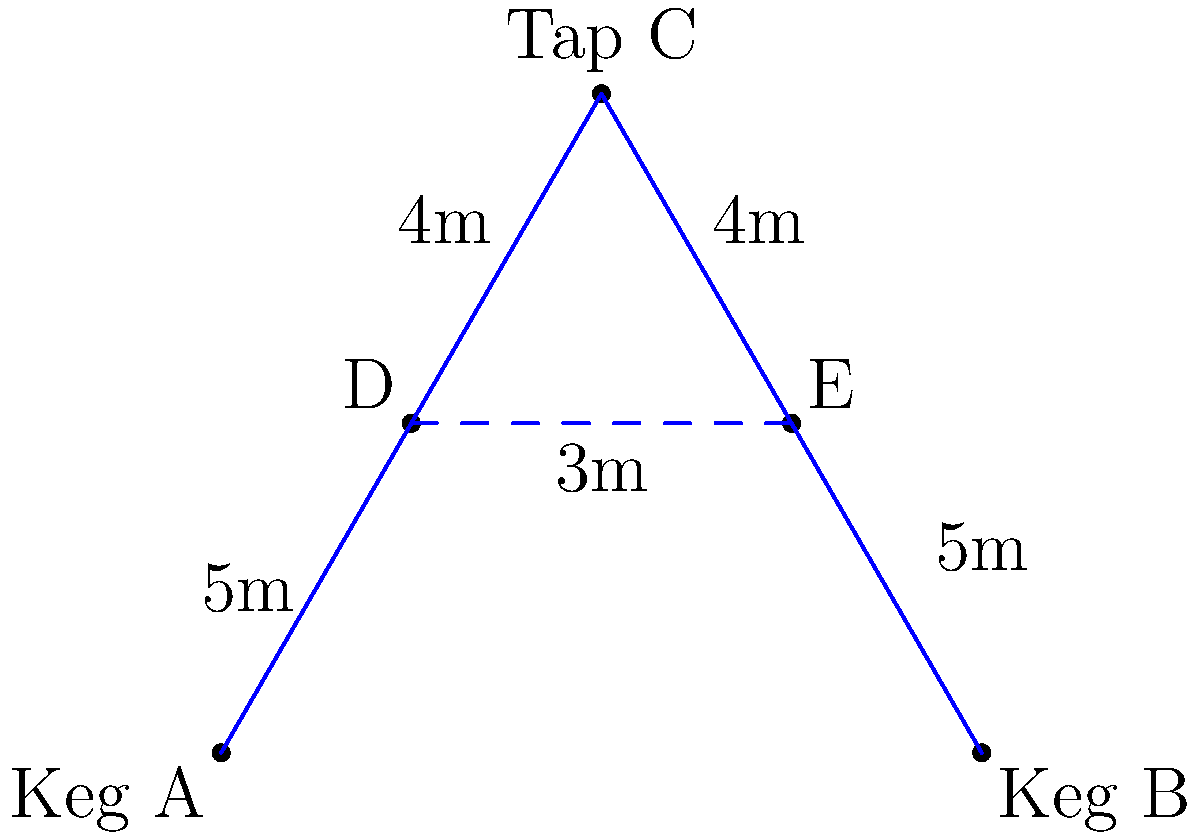You're designing the pipeline network for a beer festival. Two kegs (A and B) need to be connected to a central tap (C). The distances between points are shown in the diagram. What is the minimum total length of piping needed to connect both kegs to the tap, assuming you can place junction points (D and E) anywhere along the lines AC and BC? To solve this problem, we need to use the concept of the Steiner tree, which provides the minimum spanning network for a given set of points. Here's how we can approach this:

1) First, we observe that the optimal solution will involve two junction points (D and E) on the lines AC and BC respectively.

2) The key is to find the positions of D and E that minimize the total length of AD + BD + DE + DC.

3) In the optimal configuration, the angles ∠ADE, ∠BED, and ∠CDE should all be 120°. This is a property of Steiner points in the minimum Steiner tree.

4) Given this 120° angle condition, we can determine that triangle CDE is equilateral.

5) The height of this equilateral triangle (distance from C to DE) is $4 \sin 60° = 2\sqrt{3}$ meters.

6) The total length of the network is then:
   $AD + BE + 2CD = 5 + 5 + 2(4) = 18$ meters

7) This is less than the direct connections AC + BC = $2\sqrt{5^2 + 4^2} \approx 20.4$ meters.

Therefore, the minimum total length of piping needed is 18 meters.
Answer: 18 meters 